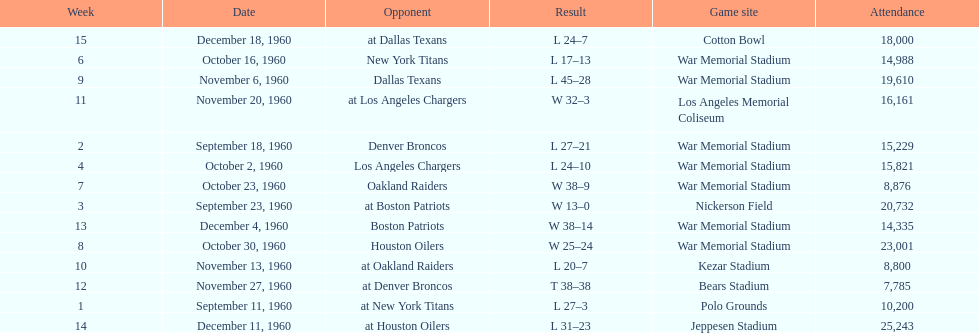What was the largest difference of points in a single game? 29. 